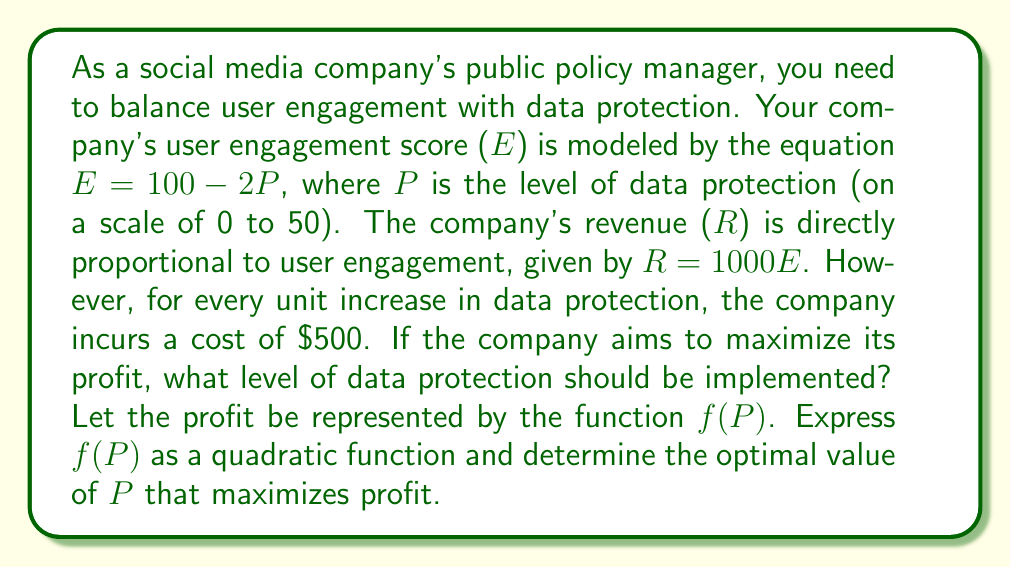Help me with this question. Let's approach this step-by-step:

1) First, we need to express revenue (R) in terms of P:
   $E = 100 - 2P$
   $R = 1000E = 1000(100 - 2P) = 100000 - 2000P$

2) The cost associated with data protection is $500P$

3) Profit (f(P)) is revenue minus cost:
   $f(P) = R - 500P = (100000 - 2000P) - 500P$
   $f(P) = 100000 - 2000P - 500P$
   $f(P) = 100000 - 2500P$

4) To express this as a quadratic function, we can add and subtract $P^2$:
   $f(P) = 100000 - 2500P + P^2 - P^2$
   $f(P) = -P^2 + (100000 - 2500P + P^2)$
   $f(P) = -P^2 + (-2500P + 100000)$
   $f(P) = -P^2 - 2500P + 100000$

5) To find the maximum of this quadratic function, we need to find the vertex. The x-coordinate of the vertex is given by $-b/(2a)$ where $a$ and $b$ are the coefficients of $P^2$ and $P$ respectively.

   $P = -(-2500)/(2(-1)) = -2500/-2 = 1250/2 = 625/2 = 31.25$

6) Since P represents a level of data protection and is described to be on a scale of 0 to 50, 31.25 is a valid solution.

Therefore, the optimal level of data protection to maximize profit is 31.25.
Answer: The optimal level of data protection to maximize profit is 31.25. 